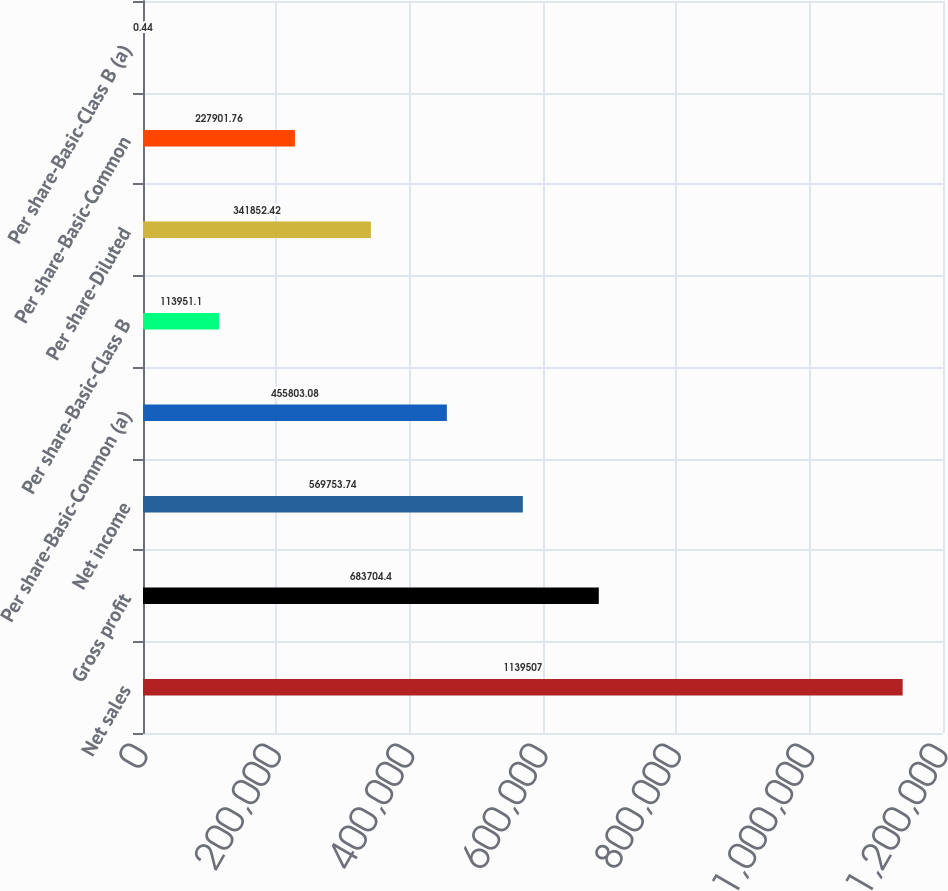Convert chart to OTSL. <chart><loc_0><loc_0><loc_500><loc_500><bar_chart><fcel>Net sales<fcel>Gross profit<fcel>Net income<fcel>Per share-Basic-Common (a)<fcel>Per share-Basic-Class B<fcel>Per share-Diluted<fcel>Per share-Basic-Common<fcel>Per share-Basic-Class B (a)<nl><fcel>1.13951e+06<fcel>683704<fcel>569754<fcel>455803<fcel>113951<fcel>341852<fcel>227902<fcel>0.44<nl></chart> 